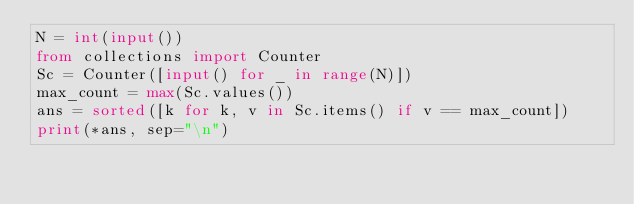Convert code to text. <code><loc_0><loc_0><loc_500><loc_500><_Python_>N = int(input())
from collections import Counter
Sc = Counter([input() for _ in range(N)])
max_count = max(Sc.values())
ans = sorted([k for k, v in Sc.items() if v == max_count])
print(*ans, sep="\n")</code> 